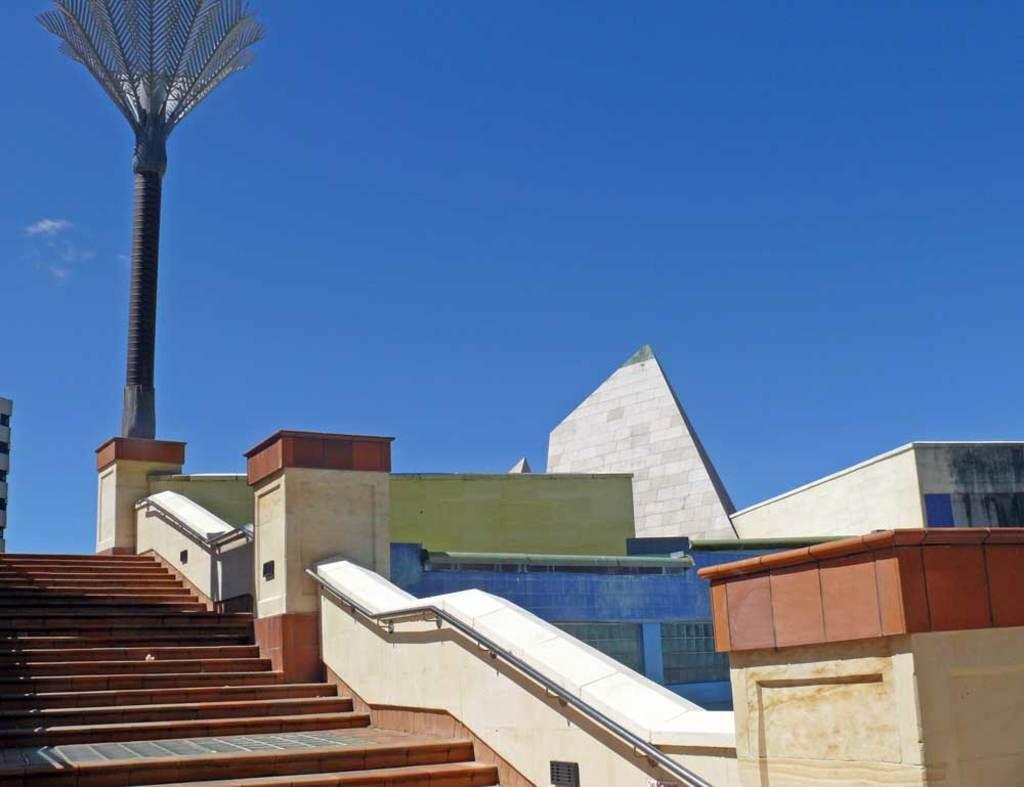What type of structure is present in the image? There is a building in the image. What can be seen on the left side of the image? There is a pole on the left side of the image. What is visible in the background of the image? The background of the image includes a blue sky. What architectural feature is present in the image? There are stairs in the image. What type of trousers are hanging on the pole in the image? There are no trousers present in the image; the pole is empty. What month is depicted in the image? The image does not depict a specific month; it only shows a blue sky in the background. 